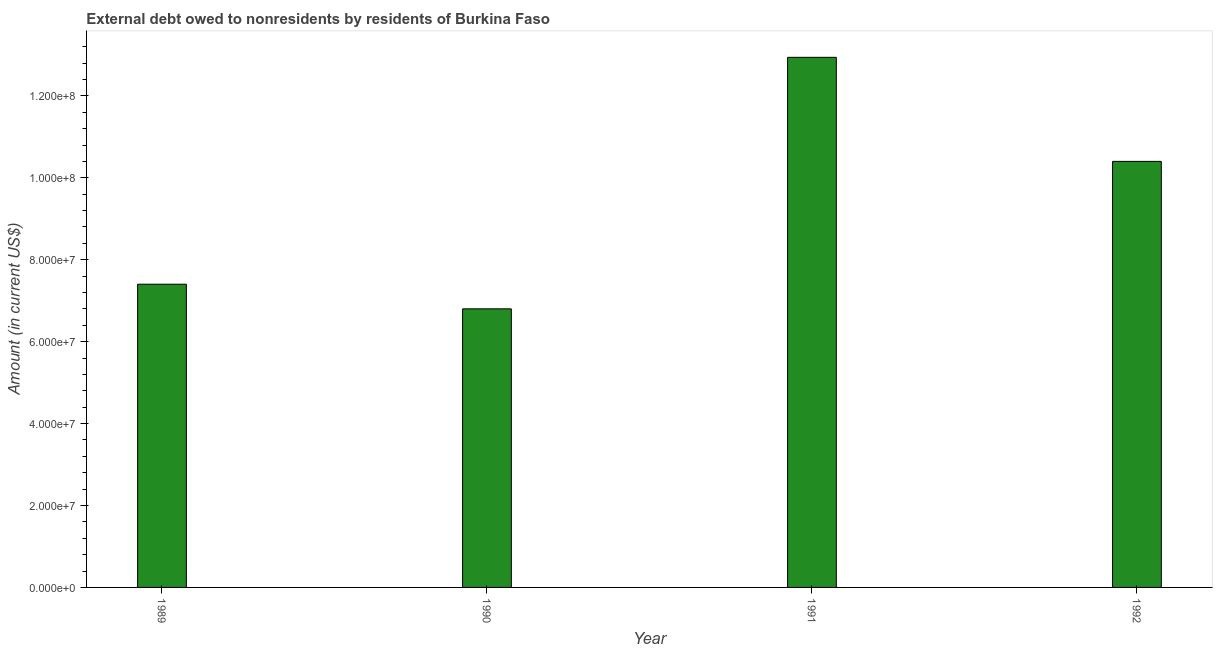What is the title of the graph?
Provide a short and direct response. External debt owed to nonresidents by residents of Burkina Faso. What is the label or title of the Y-axis?
Ensure brevity in your answer.  Amount (in current US$). What is the debt in 1989?
Your answer should be very brief. 7.40e+07. Across all years, what is the maximum debt?
Keep it short and to the point. 1.29e+08. Across all years, what is the minimum debt?
Offer a very short reply. 6.80e+07. In which year was the debt maximum?
Ensure brevity in your answer.  1991. In which year was the debt minimum?
Give a very brief answer. 1990. What is the sum of the debt?
Keep it short and to the point. 3.75e+08. What is the difference between the debt in 1989 and 1990?
Offer a terse response. 6.01e+06. What is the average debt per year?
Your answer should be compact. 9.39e+07. What is the median debt?
Your answer should be compact. 8.90e+07. In how many years, is the debt greater than 56000000 US$?
Give a very brief answer. 4. What is the ratio of the debt in 1990 to that in 1991?
Offer a terse response. 0.53. What is the difference between the highest and the second highest debt?
Your answer should be very brief. 2.54e+07. What is the difference between the highest and the lowest debt?
Give a very brief answer. 6.14e+07. What is the difference between two consecutive major ticks on the Y-axis?
Provide a succinct answer. 2.00e+07. Are the values on the major ticks of Y-axis written in scientific E-notation?
Your answer should be very brief. Yes. What is the Amount (in current US$) in 1989?
Keep it short and to the point. 7.40e+07. What is the Amount (in current US$) in 1990?
Provide a succinct answer. 6.80e+07. What is the Amount (in current US$) of 1991?
Give a very brief answer. 1.29e+08. What is the Amount (in current US$) in 1992?
Provide a succinct answer. 1.04e+08. What is the difference between the Amount (in current US$) in 1989 and 1990?
Your response must be concise. 6.01e+06. What is the difference between the Amount (in current US$) in 1989 and 1991?
Give a very brief answer. -5.54e+07. What is the difference between the Amount (in current US$) in 1989 and 1992?
Your answer should be very brief. -3.00e+07. What is the difference between the Amount (in current US$) in 1990 and 1991?
Ensure brevity in your answer.  -6.14e+07. What is the difference between the Amount (in current US$) in 1990 and 1992?
Your response must be concise. -3.60e+07. What is the difference between the Amount (in current US$) in 1991 and 1992?
Offer a very short reply. 2.54e+07. What is the ratio of the Amount (in current US$) in 1989 to that in 1990?
Keep it short and to the point. 1.09. What is the ratio of the Amount (in current US$) in 1989 to that in 1991?
Ensure brevity in your answer.  0.57. What is the ratio of the Amount (in current US$) in 1989 to that in 1992?
Offer a terse response. 0.71. What is the ratio of the Amount (in current US$) in 1990 to that in 1991?
Your response must be concise. 0.53. What is the ratio of the Amount (in current US$) in 1990 to that in 1992?
Offer a terse response. 0.65. What is the ratio of the Amount (in current US$) in 1991 to that in 1992?
Offer a very short reply. 1.24. 